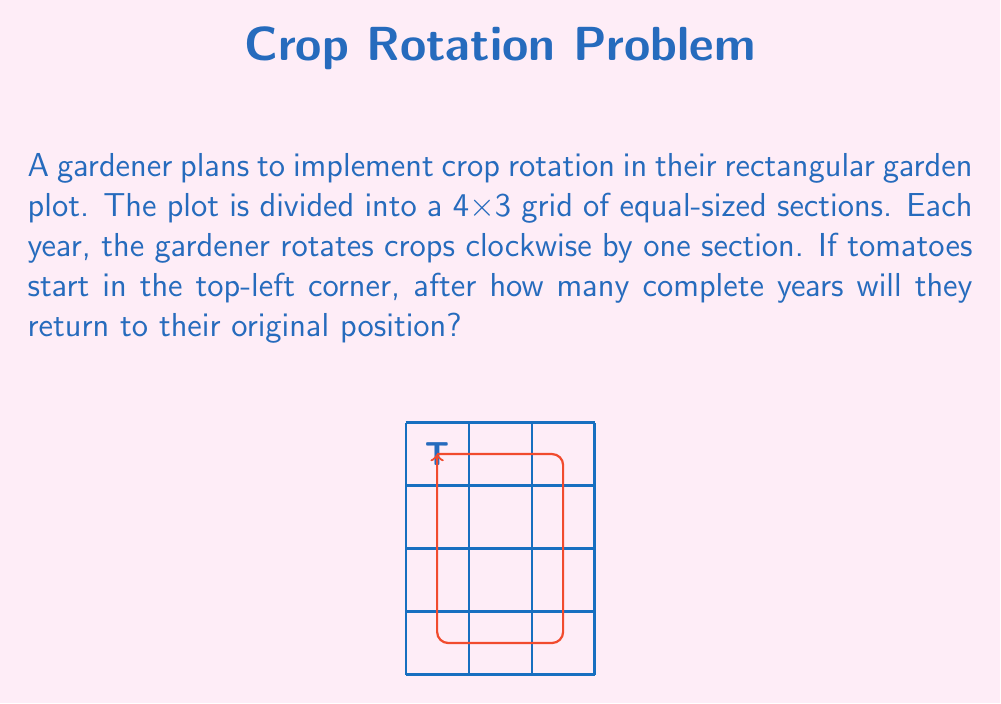Give your solution to this math problem. Let's approach this step-by-step:

1) First, we need to count the total number of sections in the garden plot:
   $$ 4 \times 3 = 12 \text{ sections} $$

2) Now, let's trace the path of the tomatoes:
   - They start in the top-left corner
   - Each year, they move one section clockwise
   - They need to complete a full circuit to return to the starting position

3) To complete a full circuit, the tomatoes need to pass through every section once before returning to the start. This means they need to move 12 times.

4) However, we're asked about complete years. We need to check if 12 moves equate to a whole number of years.

5) In one complete circuit:
   - The tomatoes move 3 times to the right
   - Then 4 times down
   - Then 3 times to the left
   - Finally, 2 times up to return to the start

6) This makes a total of 12 moves, which coincides with the number of sections. Therefore, after 12 years, the tomatoes will return to their original position.
Answer: 12 years 